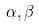Convert formula to latex. <formula><loc_0><loc_0><loc_500><loc_500>\alpha , \beta</formula> 